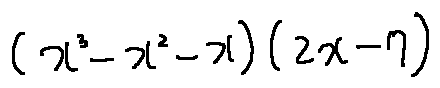<formula> <loc_0><loc_0><loc_500><loc_500>( x ^ { 3 } - x ^ { 2 } - x ) ( 2 x - 7 )</formula> 